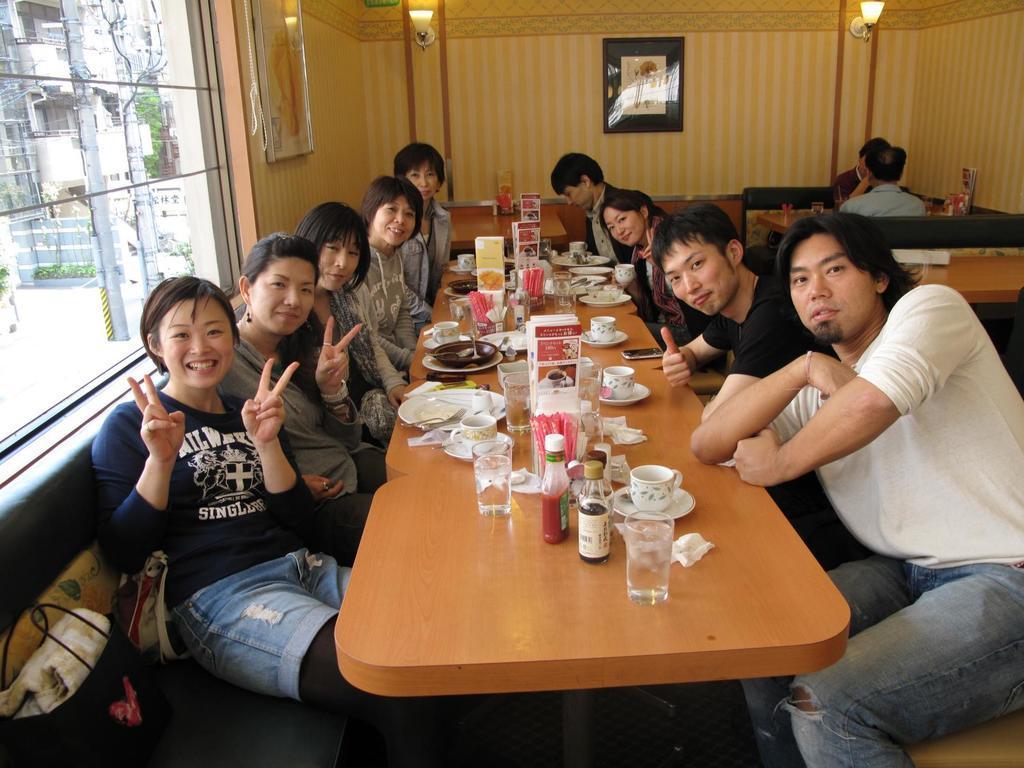Describe this image in one or two sentences. Here we can see that a group of people sitting on the chair, and in front there are some glasses and bottles and plates and some other objects on the table ,and here is the wall, and photo frame on it, and here is the window glass, and here is the lamp. 